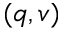Convert formula to latex. <formula><loc_0><loc_0><loc_500><loc_500>( q , v )</formula> 